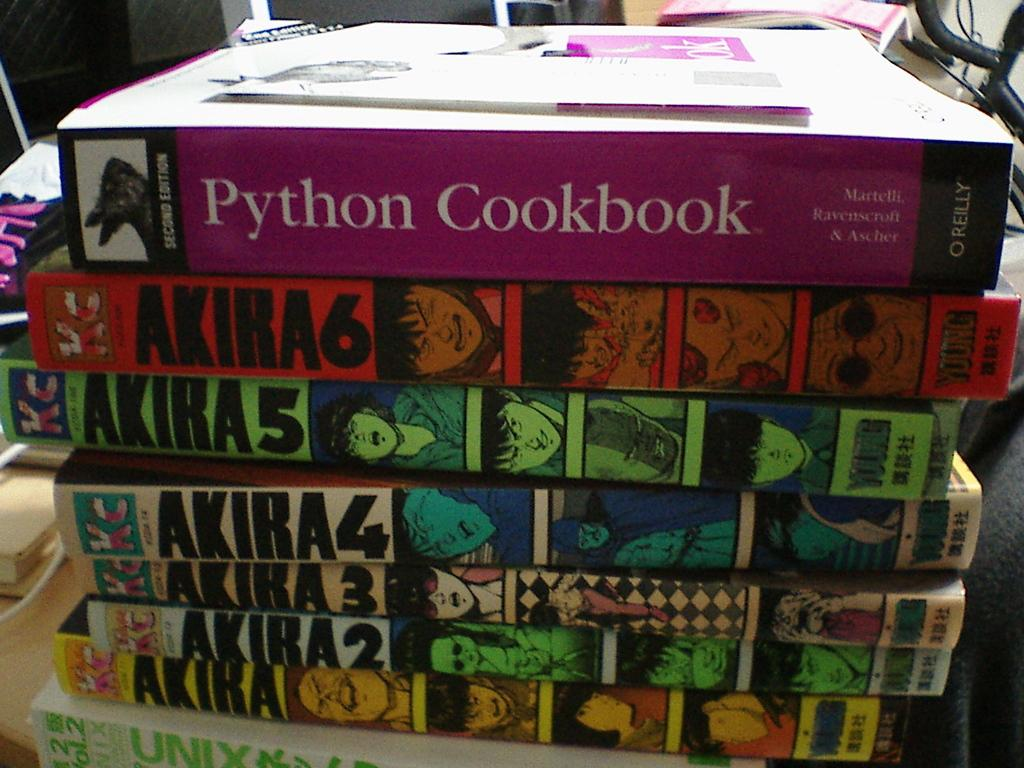<image>
Relay a brief, clear account of the picture shown. A stack of books with a cookbook on top. 